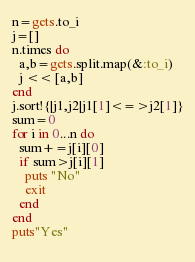Convert code to text. <code><loc_0><loc_0><loc_500><loc_500><_Ruby_>n=gets.to_i
j=[]
n.times do
  a,b=gets.split.map(&:to_i)
  j << [a,b]
end
j.sort!{|j1,j2|j1[1]<=>j2[1]}
sum=0
for i in 0...n do
  sum+=j[i][0]
  if sum>j[i][1]
    puts "No"
    exit
  end
end
puts"Yes"
  </code> 